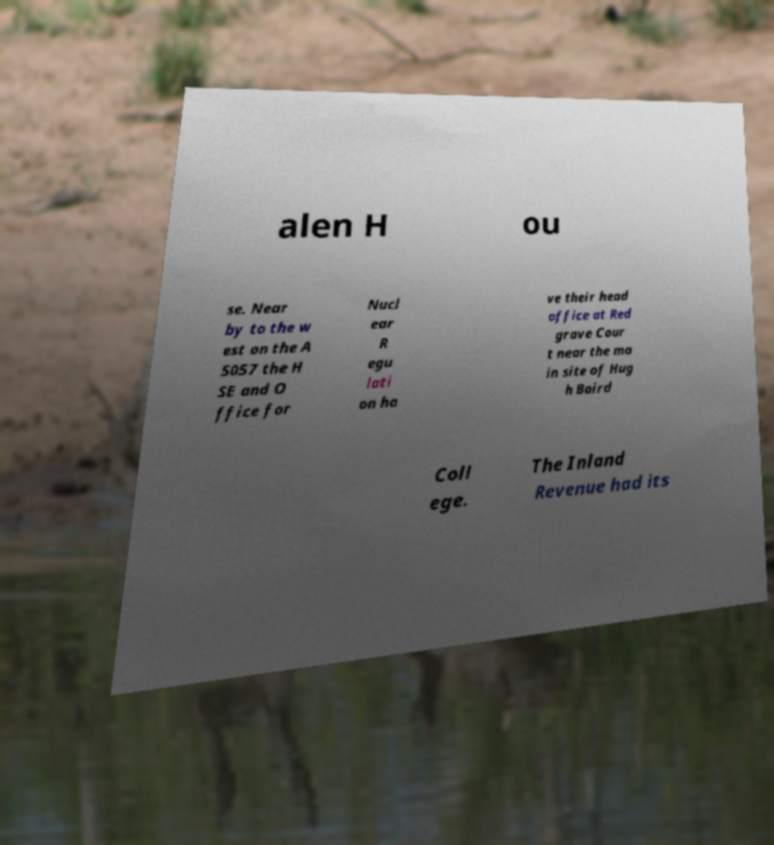Please read and relay the text visible in this image. What does it say? alen H ou se. Near by to the w est on the A 5057 the H SE and O ffice for Nucl ear R egu lati on ha ve their head office at Red grave Cour t near the ma in site of Hug h Baird Coll ege. The Inland Revenue had its 